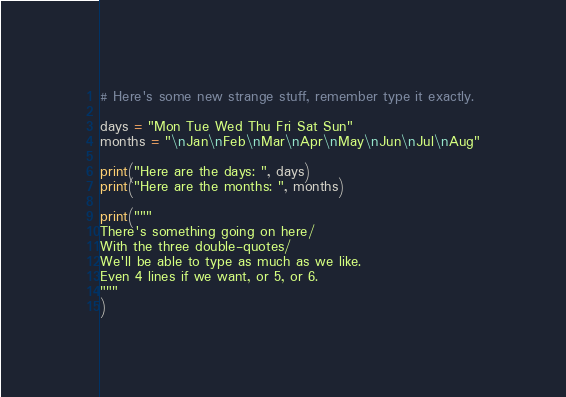Convert code to text. <code><loc_0><loc_0><loc_500><loc_500><_Python_># Here's some new strange stuff, remember type it exactly.

days = "Mon Tue Wed Thu Fri Sat Sun"
months = "\nJan\nFeb\nMar\nApr\nMay\nJun\nJul\nAug"

print("Here are the days: ", days)
print("Here are the months: ", months)

print("""
There's something going on here/
With the three double-quotes/
We'll be able to type as much as we like.
Even 4 lines if we want, or 5, or 6.
"""
)</code> 